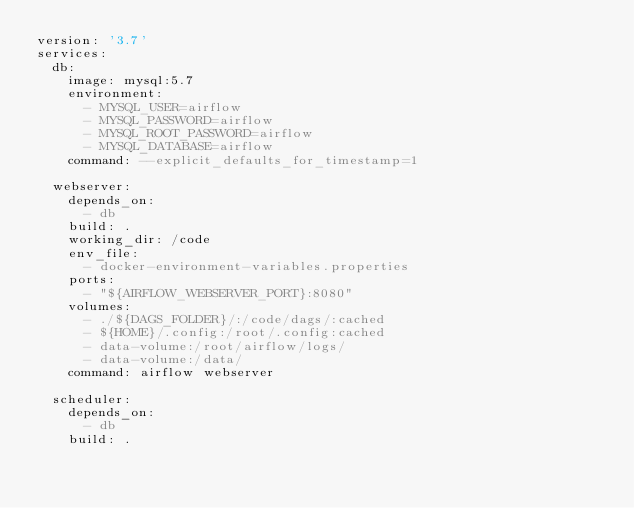Convert code to text. <code><loc_0><loc_0><loc_500><loc_500><_YAML_>version: '3.7'
services:
  db:
    image: mysql:5.7
    environment:
      - MYSQL_USER=airflow
      - MYSQL_PASSWORD=airflow
      - MYSQL_ROOT_PASSWORD=airflow
      - MYSQL_DATABASE=airflow
    command: --explicit_defaults_for_timestamp=1

  webserver:
    depends_on:
      - db
    build: .
    working_dir: /code
    env_file:
      - docker-environment-variables.properties
    ports:
      - "${AIRFLOW_WEBSERVER_PORT}:8080"
    volumes:
      - ./${DAGS_FOLDER}/:/code/dags/:cached
      - ${HOME}/.config:/root/.config:cached
      - data-volume:/root/airflow/logs/
      - data-volume:/data/
    command: airflow webserver

  scheduler:
    depends_on:
      - db
    build: .</code> 